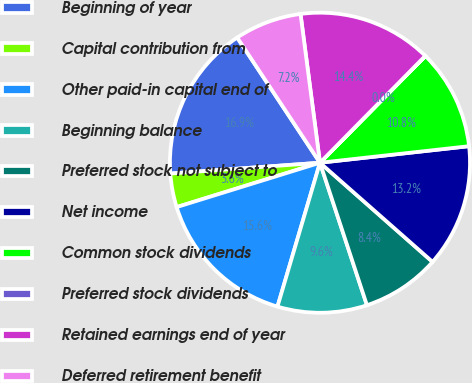Convert chart to OTSL. <chart><loc_0><loc_0><loc_500><loc_500><pie_chart><fcel>Beginning of year<fcel>Capital contribution from<fcel>Other paid-in capital end of<fcel>Beginning balance<fcel>Preferred stock not subject to<fcel>Net income<fcel>Common stock dividends<fcel>Preferred stock dividends<fcel>Retained earnings end of year<fcel>Deferred retirement benefit<nl><fcel>16.85%<fcel>3.63%<fcel>15.65%<fcel>9.64%<fcel>8.44%<fcel>13.25%<fcel>10.84%<fcel>0.02%<fcel>14.45%<fcel>7.23%<nl></chart> 